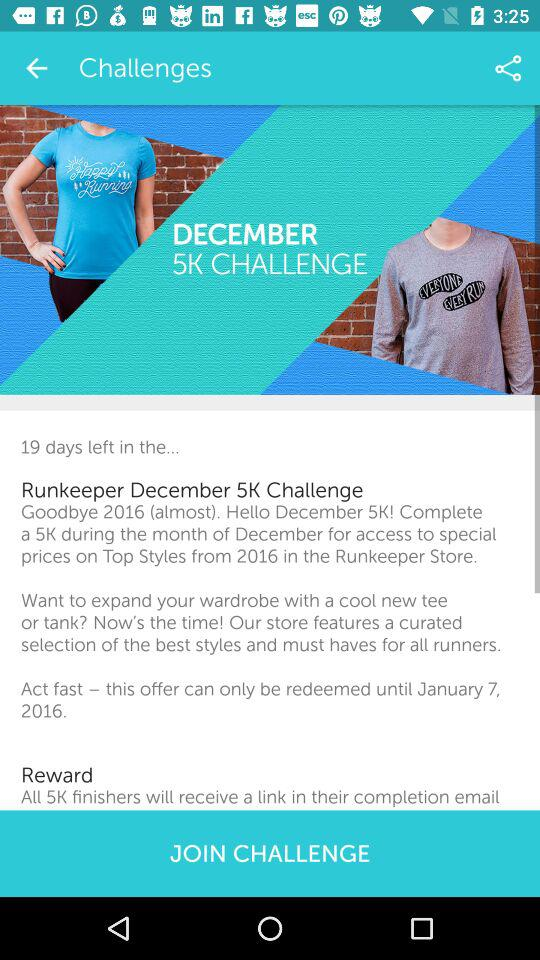What is the reward? The reward is that "All 5K finishers will receive a link in their completion email". 